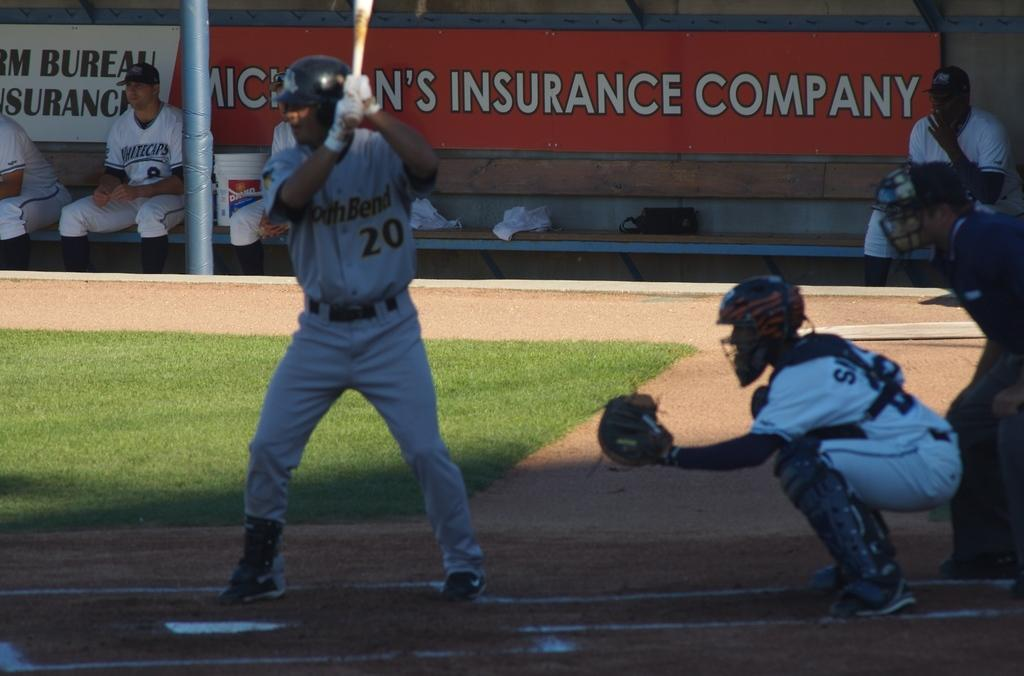Provide a one-sentence caption for the provided image. the batter and umpire of a baseball team in front of a sign of Michigan's Insurance Company. 